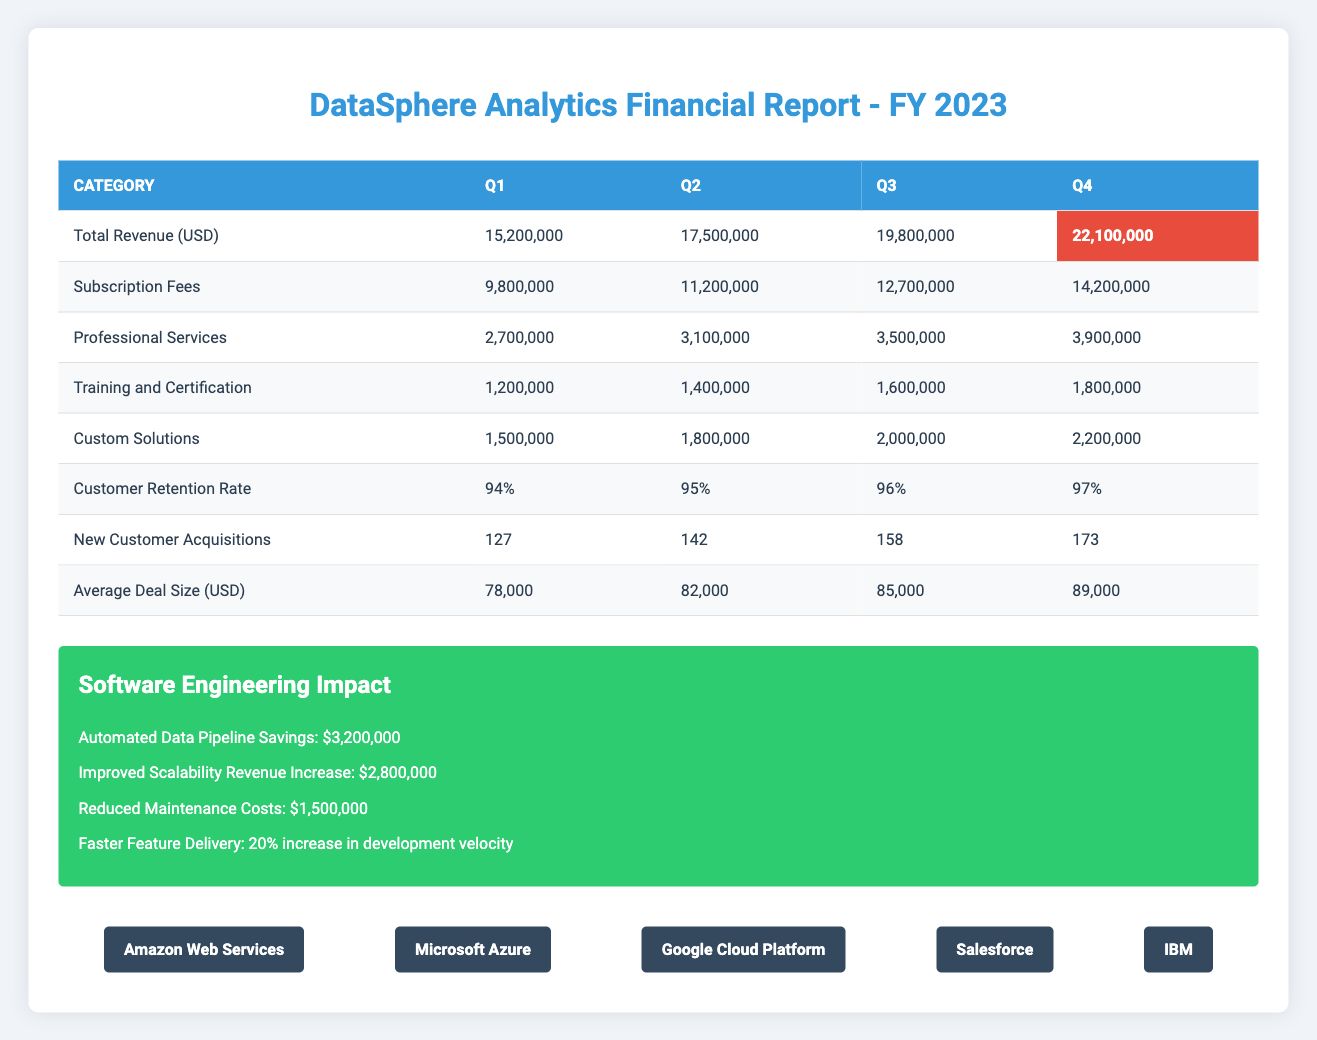What was the total revenue in Q3? The total revenue for Q3 is directly displayed in the table, listed under the "Total Revenue (USD)" row for Q3. It states the value of 19,800,000.
Answer: 19,800,000 What was the revenue from subscription fees in Q4? The revenue from subscription fees in Q4 is found in the same row as the total revenue, specifically under the "Subscription Fees" category for Q4. The value is noted as 14,200,000.
Answer: 14,200,000 How much did professional services contribute to the total revenue in Q2? The amount for professional services in Q2 can be found under the "Professional Services" row for Q2. The contribution is 3,100,000.
Answer: 3,100,000 What is the average deal size for Q1 and Q4 combined? To find the average deal size, we take the deal sizes for Q1 (78,000) and Q4 (89,000), sum them (78,000 + 89,000 = 167,000) and divide by 2 to get the average: 167,000 / 2 = 83,500.
Answer: 83,500 Is the customer retention rate higher in Q3 than in Q2? By comparing the retention rates, Q3 is noted as 96% and Q2 is 95%. Since 96% is greater than 95%, the statement is true.
Answer: Yes Did the total revenue for Q1 exceed 15 million USD? The total revenue for Q1 is explicitly stated as 15,200,000, which is greater than 15 million, rendering the statement true.
Answer: Yes What is the total revenue difference between Q4 and Q1? To find the revenue difference, we subtract Q1 total revenue (15,200,000) from Q4 total revenue (22,100,000): 22,100,000 - 15,200,000 = 6,900,000.
Answer: 6,900,000 Which quarter had the highest average deal size? We can see specific values for average deal sizes across quarters: Q1 = 78,000, Q2 = 82,000, Q3 = 85,000, and Q4 = 89,000. Since 89,000 is the highest among these, Q4 has the highest average deal size.
Answer: Q4 What revenue category shows the largest growth from Q2 to Q3? By examining the revenue breakdown, we find subscription fees for Q2 (11,200,000) and Q3 (12,700,000). The growth is noted by subtracting: 12,700,000 - 11,200,000 = 1,500,000. This category reflects the largest increase compared to others.
Answer: Subscription Fees 